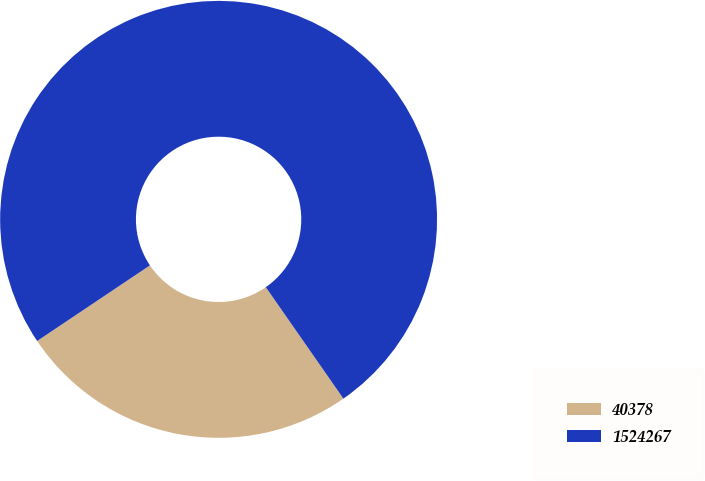Convert chart to OTSL. <chart><loc_0><loc_0><loc_500><loc_500><pie_chart><fcel>40378<fcel>1524267<nl><fcel>25.28%<fcel>74.72%<nl></chart> 